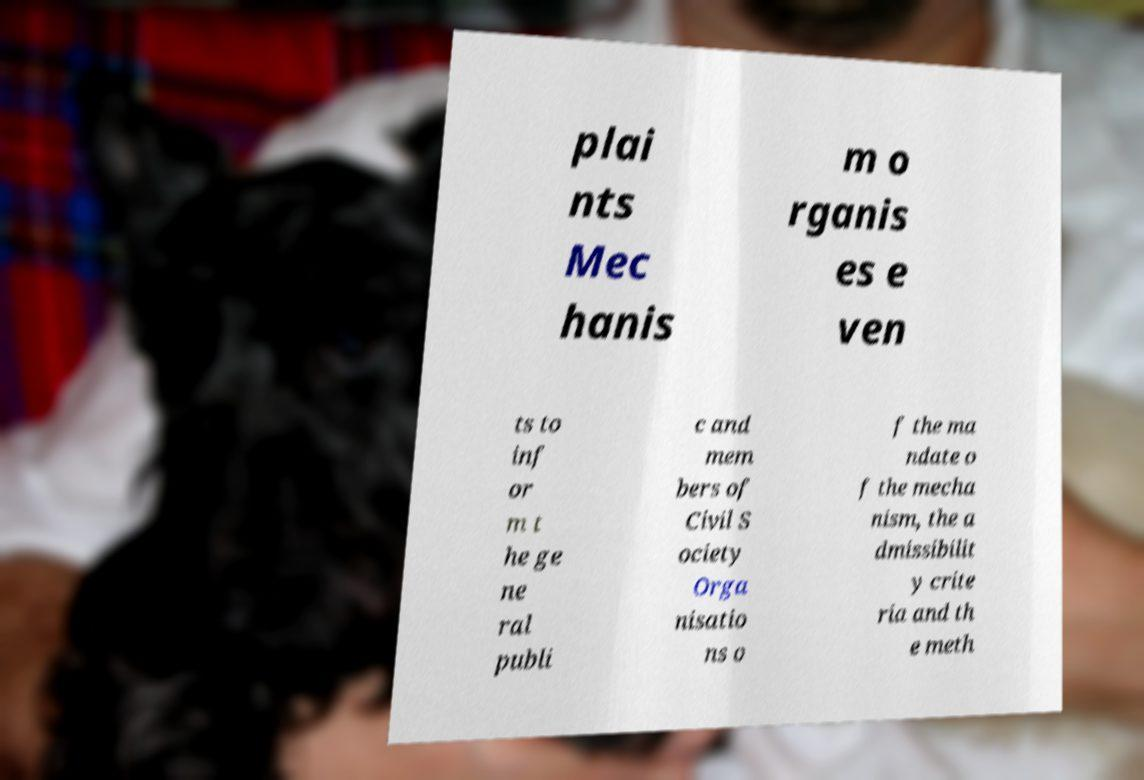I need the written content from this picture converted into text. Can you do that? plai nts Mec hanis m o rganis es e ven ts to inf or m t he ge ne ral publi c and mem bers of Civil S ociety Orga nisatio ns o f the ma ndate o f the mecha nism, the a dmissibilit y crite ria and th e meth 